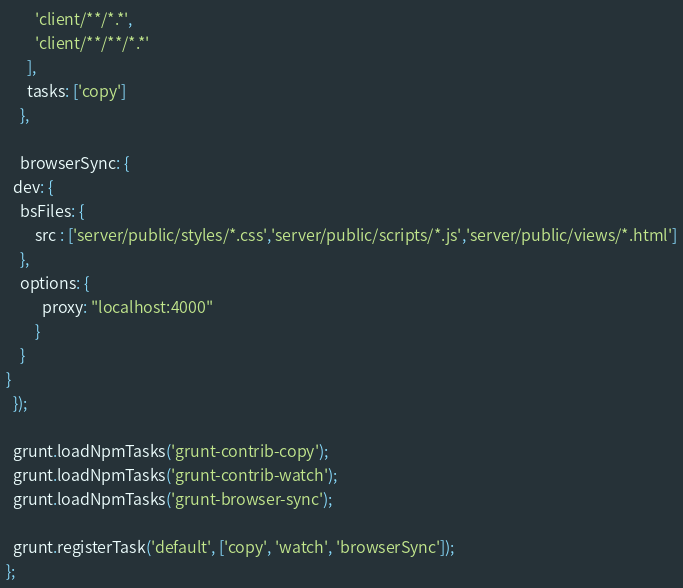<code> <loc_0><loc_0><loc_500><loc_500><_JavaScript_>        'client/**/*.*',
        'client/**/**/*.*'
      ],
      tasks: ['copy']
    },

    browserSync: {
  dev: {
    bsFiles: {
        src : ['server/public/styles/*.css','server/public/scripts/*.js','server/public/views/*.html']
    },
    options: {
          proxy: "localhost:4000"
        }
    }
}
  });

  grunt.loadNpmTasks('grunt-contrib-copy');
  grunt.loadNpmTasks('grunt-contrib-watch');
  grunt.loadNpmTasks('grunt-browser-sync');

  grunt.registerTask('default', ['copy', 'watch', 'browserSync']);
};
</code> 